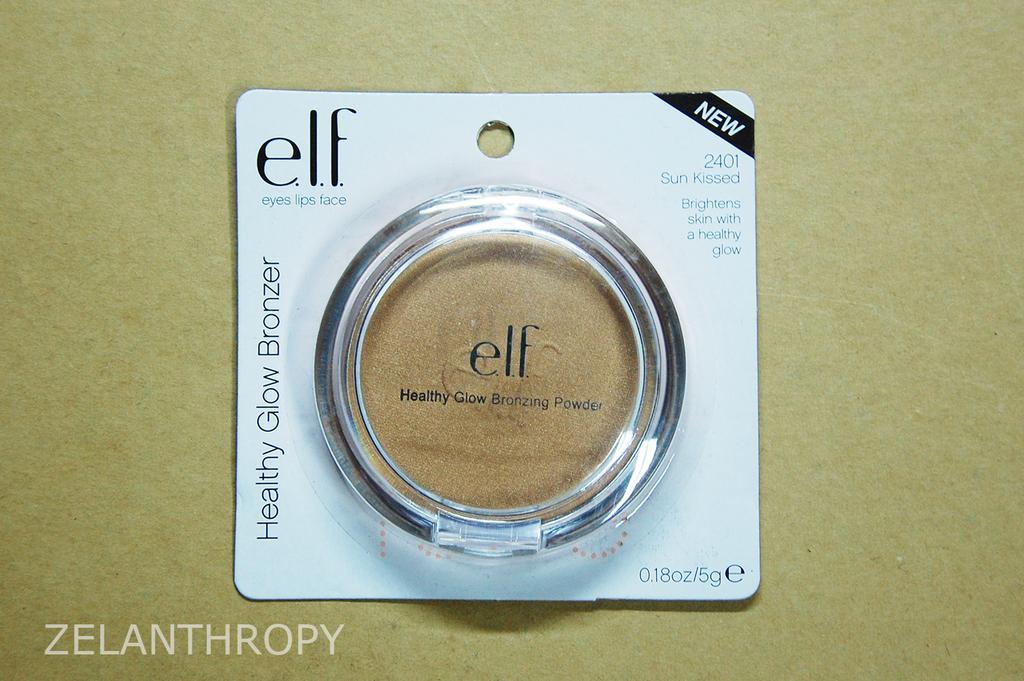In one or two sentences, can you explain what this image depicts? In this picture we can see a healthy glow bronzing powder in a packet. We can see some text and numbers on this packet. There is a text visible in the bottom left. We can see a creamy background. 